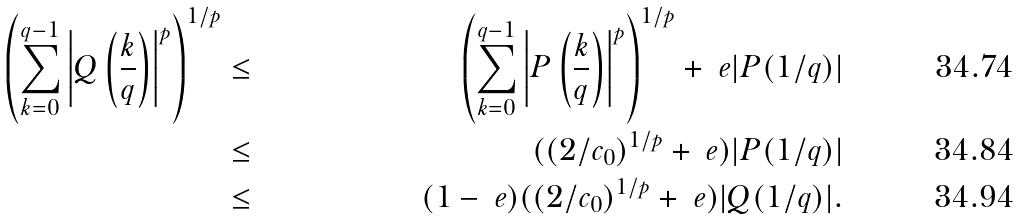<formula> <loc_0><loc_0><loc_500><loc_500>\left ( \sum _ { k = 0 } ^ { q - 1 } \left | Q \left ( \frac { k } { q } \right ) \right | ^ { p } \right ) ^ { 1 / p } & \leq & \left ( \sum _ { k = 0 } ^ { q - 1 } \left | P \left ( \frac { k } { q } \right ) \right | ^ { p } \right ) ^ { 1 / p } + \ e | P ( 1 / q ) | \\ & \leq & ( ( 2 / c _ { 0 } ) ^ { 1 / p } + \ e ) | P ( 1 / q ) | \\ & \leq & ( 1 - \ e ) ( ( 2 / c _ { 0 } ) ^ { 1 / p } + \ e ) | Q ( 1 / q ) | .</formula> 